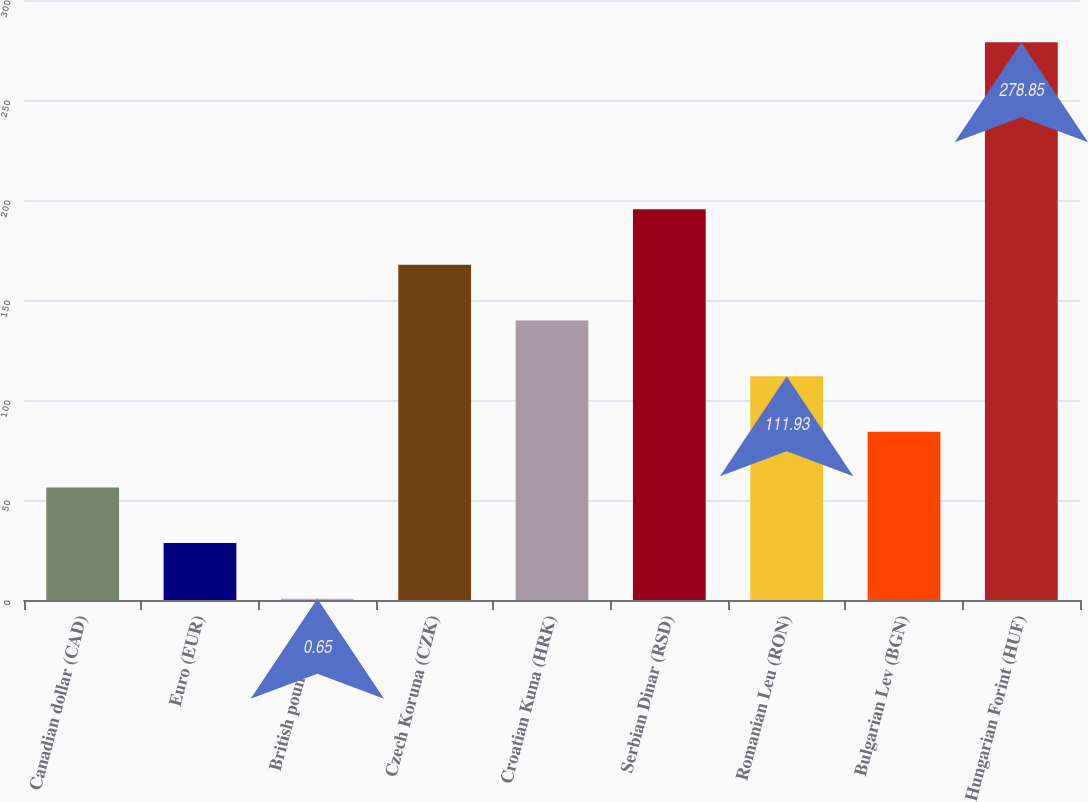Convert chart to OTSL. <chart><loc_0><loc_0><loc_500><loc_500><bar_chart><fcel>Canadian dollar (CAD)<fcel>Euro (EUR)<fcel>British pound (GBP)<fcel>Czech Koruna (CZK)<fcel>Croatian Kuna (HRK)<fcel>Serbian Dinar (RSD)<fcel>Romanian Leu (RON)<fcel>Bulgarian Lev (BGN)<fcel>Hungarian Forint (HUF)<nl><fcel>56.29<fcel>28.47<fcel>0.65<fcel>167.57<fcel>139.75<fcel>195.39<fcel>111.93<fcel>84.11<fcel>278.85<nl></chart> 